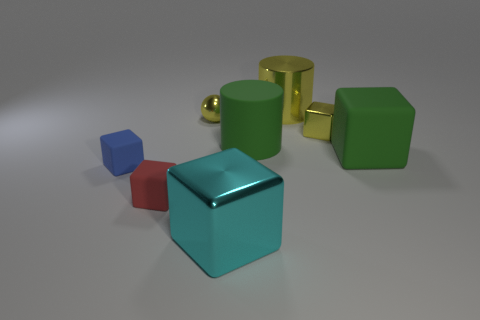Is the number of green blocks that are on the left side of the big cyan shiny thing less than the number of large green matte objects?
Your response must be concise. Yes. What number of other objects are there of the same shape as the large cyan shiny object?
Your answer should be very brief. 4. Is there anything else that is the same color as the matte cylinder?
Keep it short and to the point. Yes. There is a big shiny block; is its color the same as the big cube that is to the right of the green cylinder?
Your response must be concise. No. What number of other objects are there of the same size as the blue cube?
Provide a short and direct response. 3. There is a block that is the same color as the small sphere; what is its size?
Your answer should be compact. Small. What number of cylinders are either small yellow objects or small cyan rubber objects?
Give a very brief answer. 0. Is the shape of the metal object that is to the left of the cyan metallic thing the same as  the red object?
Offer a terse response. No. Are there more metal things that are behind the green matte block than tiny blue rubber blocks?
Your answer should be very brief. Yes. There is a rubber cylinder that is the same size as the cyan thing; what color is it?
Give a very brief answer. Green. 